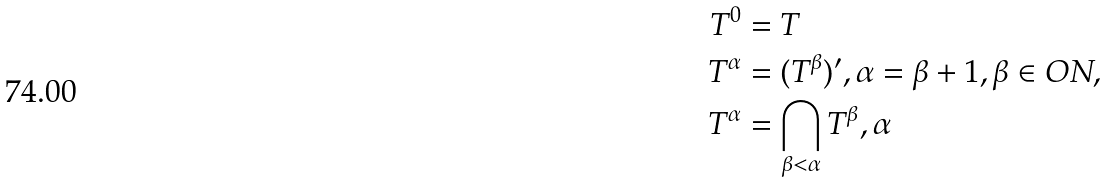Convert formula to latex. <formula><loc_0><loc_0><loc_500><loc_500>T ^ { 0 } & = T \\ T ^ { \alpha } & = ( T ^ { \beta } ) ^ { \prime } , \alpha = \beta + 1 , \beta \in O N , \\ T ^ { \alpha } & = \bigcap _ { \beta < \alpha } T ^ { \beta } , \alpha</formula> 